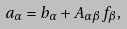Convert formula to latex. <formula><loc_0><loc_0><loc_500><loc_500>a _ { \alpha } = b _ { \alpha } + A _ { \alpha \beta } f _ { \beta } ,</formula> 